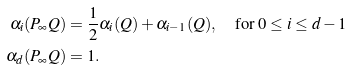<formula> <loc_0><loc_0><loc_500><loc_500>\alpha _ { i } ( P _ { \infty } Q ) & = \frac { 1 } { 2 } \alpha _ { i } ( Q ) + \alpha _ { i - 1 } ( Q ) , \quad \text {for } 0 \leq i \leq d - 1 \\ \alpha _ { d } ( P _ { \infty } Q ) & = 1 .</formula> 